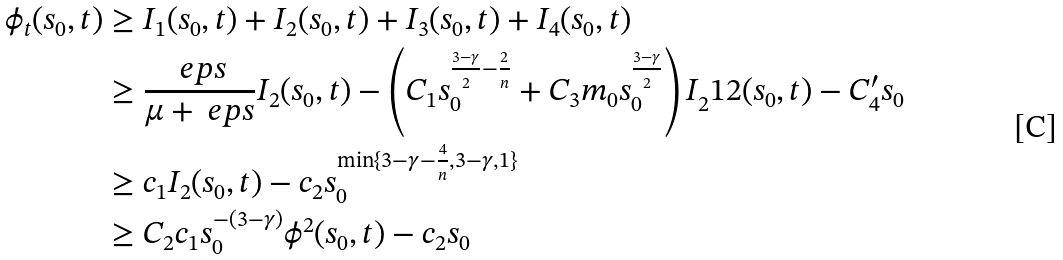<formula> <loc_0><loc_0><loc_500><loc_500>\phi _ { t } ( s _ { 0 } , t ) & \geq I _ { 1 } ( s _ { 0 } , t ) + I _ { 2 } ( s _ { 0 } , t ) + I _ { 3 } ( s _ { 0 } , t ) + I _ { 4 } ( s _ { 0 } , t ) \\ & \geq \frac { \ e p s } { \mu + \ e p s } I _ { 2 } ( s _ { 0 } , t ) - \left ( C _ { 1 } s _ { 0 } ^ { \frac { 3 - \gamma } { 2 } - \frac { 2 } { n } } + C _ { 3 } m _ { 0 } s _ { 0 } ^ { \frac { 3 - \gamma } { 2 } } \right ) I _ { 2 } ^ { } { 1 } 2 ( s _ { 0 } , t ) - C _ { 4 } ^ { \prime } s _ { 0 } \\ & \geq c _ { 1 } I _ { 2 } ( s _ { 0 } , t ) - c _ { 2 } s _ { 0 } ^ { \min \{ 3 - \gamma - \frac { 4 } { n } , 3 - \gamma , 1 \} } \\ & \geq C _ { 2 } c _ { 1 } s _ { 0 } ^ { - ( 3 - \gamma ) } \phi ^ { 2 } ( s _ { 0 } , t ) - c _ { 2 } s _ { 0 }</formula> 